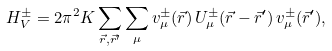<formula> <loc_0><loc_0><loc_500><loc_500>H _ { V } ^ { \pm } = 2 \pi ^ { 2 } K \sum _ { \vec { r } , \vec { r } ^ { \prime } } \sum _ { \mu } v _ { \mu } ^ { \pm } ( \vec { r } ) \, U _ { \mu } ^ { \pm } ( \vec { r } - \vec { r } ^ { \prime } ) \, v _ { \mu } ^ { \pm } ( \vec { r } ^ { \prime } ) ,</formula> 